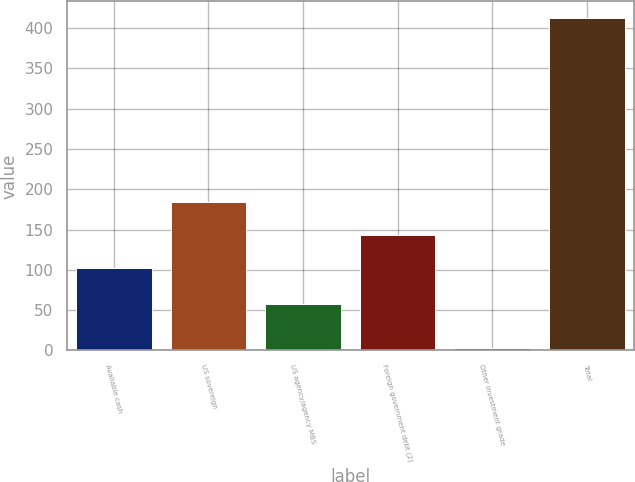Convert chart. <chart><loc_0><loc_0><loc_500><loc_500><bar_chart><fcel>Available cash<fcel>US sovereign<fcel>US agency/agency MBS<fcel>Foreign government debt (2)<fcel>Other investment grade<fcel>Total<nl><fcel>102.7<fcel>184.6<fcel>57.1<fcel>143.65<fcel>3.1<fcel>412.6<nl></chart> 